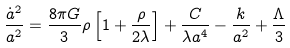Convert formula to latex. <formula><loc_0><loc_0><loc_500><loc_500>\frac { { \dot { a } } ^ { 2 } } { a ^ { 2 } } = \frac { 8 \pi G } { 3 } \rho \left [ 1 + \frac { \rho } { 2 \lambda } \right ] + \frac { C } { \lambda a ^ { 4 } } - \frac { k } { a ^ { 2 } } + \frac { \Lambda } { 3 }</formula> 